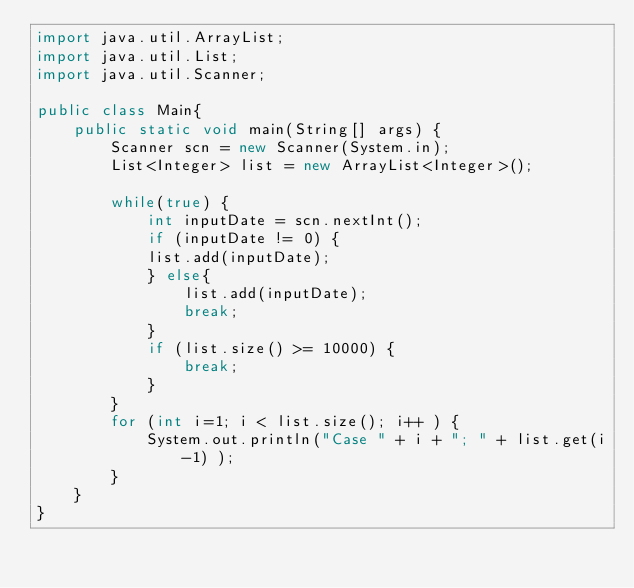Convert code to text. <code><loc_0><loc_0><loc_500><loc_500><_Java_>import java.util.ArrayList;
import java.util.List;
import java.util.Scanner;

public class Main{
    public static void main(String[] args) {
    	Scanner scn = new Scanner(System.in);
    	List<Integer> list = new ArrayList<Integer>();

    	while(true) {
    		int inputDate = scn.nextInt();
    		if (inputDate != 0) {
    		list.add(inputDate);
    		} else{
    			list.add(inputDate);
    			break;
    		}
    		if (list.size() >= 10000) {
    			break;
    		}
    	}
    	for (int i=1; i < list.size(); i++ ) {
    		System.out.println("Case " + i + "; " + list.get(i-1) );
    	}
    }
}
</code> 